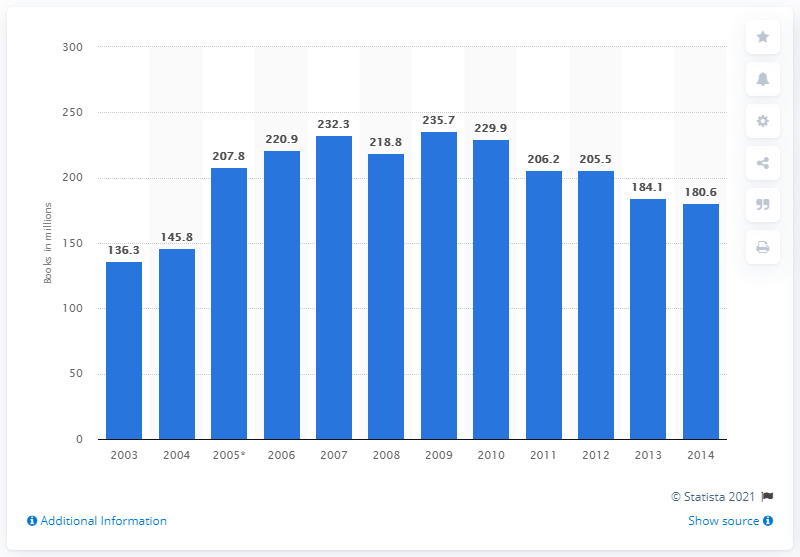Specify some key components in this picture. In 2014, a total of 180.6 books were sold in the UK. In 2009, a total of 235.7 books were sold. 